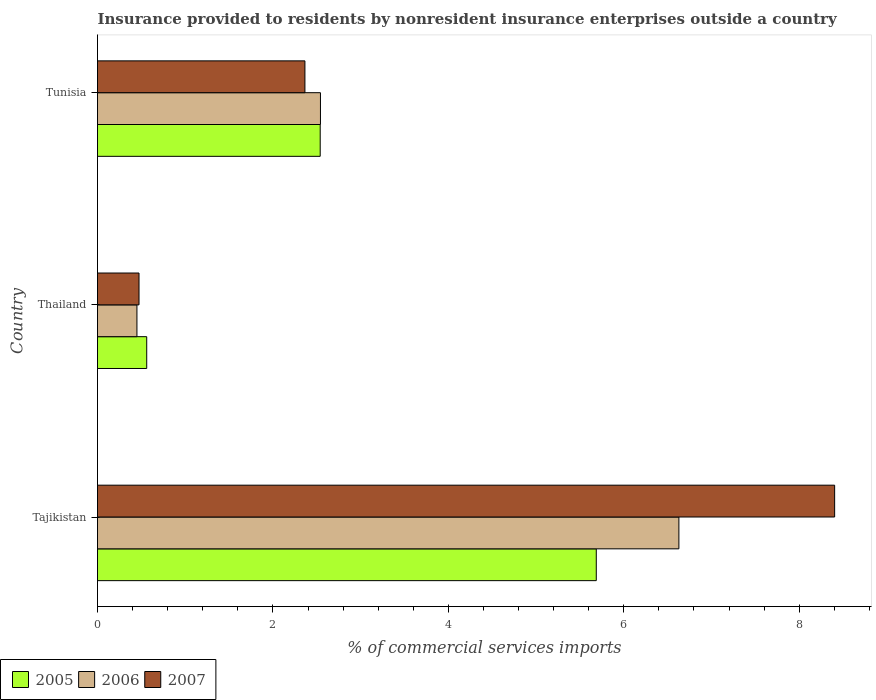How many different coloured bars are there?
Your answer should be very brief. 3. How many groups of bars are there?
Offer a very short reply. 3. What is the label of the 2nd group of bars from the top?
Keep it short and to the point. Thailand. In how many cases, is the number of bars for a given country not equal to the number of legend labels?
Your response must be concise. 0. What is the Insurance provided to residents in 2005 in Tunisia?
Offer a terse response. 2.54. Across all countries, what is the maximum Insurance provided to residents in 2005?
Your response must be concise. 5.69. Across all countries, what is the minimum Insurance provided to residents in 2007?
Provide a succinct answer. 0.47. In which country was the Insurance provided to residents in 2007 maximum?
Offer a very short reply. Tajikistan. In which country was the Insurance provided to residents in 2007 minimum?
Make the answer very short. Thailand. What is the total Insurance provided to residents in 2005 in the graph?
Offer a terse response. 8.79. What is the difference between the Insurance provided to residents in 2006 in Tajikistan and that in Thailand?
Your answer should be compact. 6.18. What is the difference between the Insurance provided to residents in 2005 in Thailand and the Insurance provided to residents in 2006 in Tajikistan?
Give a very brief answer. -6.07. What is the average Insurance provided to residents in 2006 per country?
Your response must be concise. 3.21. What is the difference between the Insurance provided to residents in 2005 and Insurance provided to residents in 2007 in Thailand?
Give a very brief answer. 0.09. What is the ratio of the Insurance provided to residents in 2007 in Thailand to that in Tunisia?
Your answer should be compact. 0.2. Is the Insurance provided to residents in 2005 in Tajikistan less than that in Tunisia?
Your answer should be compact. No. Is the difference between the Insurance provided to residents in 2005 in Tajikistan and Thailand greater than the difference between the Insurance provided to residents in 2007 in Tajikistan and Thailand?
Your response must be concise. No. What is the difference between the highest and the second highest Insurance provided to residents in 2007?
Provide a short and direct response. 6.04. What is the difference between the highest and the lowest Insurance provided to residents in 2005?
Offer a very short reply. 5.13. Is the sum of the Insurance provided to residents in 2007 in Thailand and Tunisia greater than the maximum Insurance provided to residents in 2006 across all countries?
Offer a terse response. No. Is it the case that in every country, the sum of the Insurance provided to residents in 2005 and Insurance provided to residents in 2007 is greater than the Insurance provided to residents in 2006?
Provide a short and direct response. Yes. How many bars are there?
Provide a short and direct response. 9. Are all the bars in the graph horizontal?
Provide a succinct answer. Yes. What is the difference between two consecutive major ticks on the X-axis?
Keep it short and to the point. 2. Are the values on the major ticks of X-axis written in scientific E-notation?
Make the answer very short. No. How are the legend labels stacked?
Provide a short and direct response. Horizontal. What is the title of the graph?
Your answer should be compact. Insurance provided to residents by nonresident insurance enterprises outside a country. What is the label or title of the X-axis?
Make the answer very short. % of commercial services imports. What is the label or title of the Y-axis?
Your answer should be very brief. Country. What is the % of commercial services imports in 2005 in Tajikistan?
Provide a succinct answer. 5.69. What is the % of commercial services imports in 2006 in Tajikistan?
Provide a succinct answer. 6.63. What is the % of commercial services imports in 2007 in Tajikistan?
Offer a very short reply. 8.4. What is the % of commercial services imports of 2005 in Thailand?
Ensure brevity in your answer.  0.56. What is the % of commercial services imports of 2006 in Thailand?
Your answer should be very brief. 0.45. What is the % of commercial services imports in 2007 in Thailand?
Give a very brief answer. 0.47. What is the % of commercial services imports in 2005 in Tunisia?
Ensure brevity in your answer.  2.54. What is the % of commercial services imports of 2006 in Tunisia?
Your response must be concise. 2.54. What is the % of commercial services imports in 2007 in Tunisia?
Your answer should be very brief. 2.36. Across all countries, what is the maximum % of commercial services imports of 2005?
Offer a very short reply. 5.69. Across all countries, what is the maximum % of commercial services imports of 2006?
Your answer should be very brief. 6.63. Across all countries, what is the maximum % of commercial services imports in 2007?
Provide a succinct answer. 8.4. Across all countries, what is the minimum % of commercial services imports in 2005?
Ensure brevity in your answer.  0.56. Across all countries, what is the minimum % of commercial services imports of 2006?
Give a very brief answer. 0.45. Across all countries, what is the minimum % of commercial services imports in 2007?
Ensure brevity in your answer.  0.47. What is the total % of commercial services imports of 2005 in the graph?
Give a very brief answer. 8.79. What is the total % of commercial services imports in 2006 in the graph?
Ensure brevity in your answer.  9.62. What is the total % of commercial services imports of 2007 in the graph?
Ensure brevity in your answer.  11.24. What is the difference between the % of commercial services imports of 2005 in Tajikistan and that in Thailand?
Ensure brevity in your answer.  5.13. What is the difference between the % of commercial services imports of 2006 in Tajikistan and that in Thailand?
Offer a terse response. 6.18. What is the difference between the % of commercial services imports of 2007 in Tajikistan and that in Thailand?
Keep it short and to the point. 7.93. What is the difference between the % of commercial services imports of 2005 in Tajikistan and that in Tunisia?
Give a very brief answer. 3.15. What is the difference between the % of commercial services imports of 2006 in Tajikistan and that in Tunisia?
Make the answer very short. 4.09. What is the difference between the % of commercial services imports of 2007 in Tajikistan and that in Tunisia?
Ensure brevity in your answer.  6.04. What is the difference between the % of commercial services imports in 2005 in Thailand and that in Tunisia?
Make the answer very short. -1.98. What is the difference between the % of commercial services imports of 2006 in Thailand and that in Tunisia?
Your answer should be very brief. -2.09. What is the difference between the % of commercial services imports of 2007 in Thailand and that in Tunisia?
Your answer should be very brief. -1.89. What is the difference between the % of commercial services imports of 2005 in Tajikistan and the % of commercial services imports of 2006 in Thailand?
Offer a terse response. 5.24. What is the difference between the % of commercial services imports in 2005 in Tajikistan and the % of commercial services imports in 2007 in Thailand?
Keep it short and to the point. 5.21. What is the difference between the % of commercial services imports in 2006 in Tajikistan and the % of commercial services imports in 2007 in Thailand?
Offer a terse response. 6.16. What is the difference between the % of commercial services imports in 2005 in Tajikistan and the % of commercial services imports in 2006 in Tunisia?
Provide a succinct answer. 3.14. What is the difference between the % of commercial services imports of 2005 in Tajikistan and the % of commercial services imports of 2007 in Tunisia?
Ensure brevity in your answer.  3.32. What is the difference between the % of commercial services imports in 2006 in Tajikistan and the % of commercial services imports in 2007 in Tunisia?
Your answer should be very brief. 4.26. What is the difference between the % of commercial services imports in 2005 in Thailand and the % of commercial services imports in 2006 in Tunisia?
Your response must be concise. -1.98. What is the difference between the % of commercial services imports in 2005 in Thailand and the % of commercial services imports in 2007 in Tunisia?
Offer a very short reply. -1.8. What is the difference between the % of commercial services imports in 2006 in Thailand and the % of commercial services imports in 2007 in Tunisia?
Keep it short and to the point. -1.92. What is the average % of commercial services imports in 2005 per country?
Provide a short and direct response. 2.93. What is the average % of commercial services imports of 2006 per country?
Make the answer very short. 3.21. What is the average % of commercial services imports of 2007 per country?
Make the answer very short. 3.75. What is the difference between the % of commercial services imports of 2005 and % of commercial services imports of 2006 in Tajikistan?
Provide a succinct answer. -0.94. What is the difference between the % of commercial services imports of 2005 and % of commercial services imports of 2007 in Tajikistan?
Your answer should be very brief. -2.72. What is the difference between the % of commercial services imports of 2006 and % of commercial services imports of 2007 in Tajikistan?
Provide a short and direct response. -1.78. What is the difference between the % of commercial services imports in 2005 and % of commercial services imports in 2006 in Thailand?
Offer a very short reply. 0.11. What is the difference between the % of commercial services imports of 2005 and % of commercial services imports of 2007 in Thailand?
Your answer should be compact. 0.09. What is the difference between the % of commercial services imports of 2006 and % of commercial services imports of 2007 in Thailand?
Your response must be concise. -0.02. What is the difference between the % of commercial services imports in 2005 and % of commercial services imports in 2006 in Tunisia?
Ensure brevity in your answer.  -0. What is the difference between the % of commercial services imports in 2005 and % of commercial services imports in 2007 in Tunisia?
Offer a terse response. 0.17. What is the difference between the % of commercial services imports of 2006 and % of commercial services imports of 2007 in Tunisia?
Provide a short and direct response. 0.18. What is the ratio of the % of commercial services imports of 2005 in Tajikistan to that in Thailand?
Ensure brevity in your answer.  10.14. What is the ratio of the % of commercial services imports in 2006 in Tajikistan to that in Thailand?
Your response must be concise. 14.75. What is the ratio of the % of commercial services imports in 2007 in Tajikistan to that in Thailand?
Offer a terse response. 17.76. What is the ratio of the % of commercial services imports in 2005 in Tajikistan to that in Tunisia?
Offer a terse response. 2.24. What is the ratio of the % of commercial services imports of 2006 in Tajikistan to that in Tunisia?
Provide a short and direct response. 2.61. What is the ratio of the % of commercial services imports of 2007 in Tajikistan to that in Tunisia?
Offer a terse response. 3.55. What is the ratio of the % of commercial services imports in 2005 in Thailand to that in Tunisia?
Keep it short and to the point. 0.22. What is the ratio of the % of commercial services imports of 2006 in Thailand to that in Tunisia?
Make the answer very short. 0.18. What is the ratio of the % of commercial services imports in 2007 in Thailand to that in Tunisia?
Make the answer very short. 0.2. What is the difference between the highest and the second highest % of commercial services imports of 2005?
Make the answer very short. 3.15. What is the difference between the highest and the second highest % of commercial services imports of 2006?
Provide a succinct answer. 4.09. What is the difference between the highest and the second highest % of commercial services imports in 2007?
Your answer should be very brief. 6.04. What is the difference between the highest and the lowest % of commercial services imports in 2005?
Provide a short and direct response. 5.13. What is the difference between the highest and the lowest % of commercial services imports of 2006?
Your answer should be compact. 6.18. What is the difference between the highest and the lowest % of commercial services imports of 2007?
Provide a short and direct response. 7.93. 